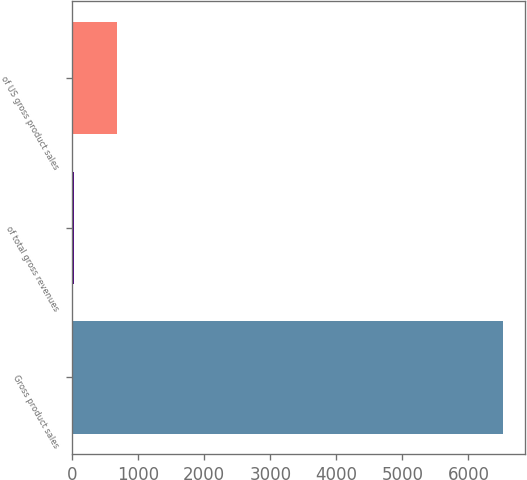<chart> <loc_0><loc_0><loc_500><loc_500><bar_chart><fcel>Gross product sales<fcel>of total gross revenues<fcel>of US gross product sales<nl><fcel>6523<fcel>35<fcel>683.8<nl></chart> 